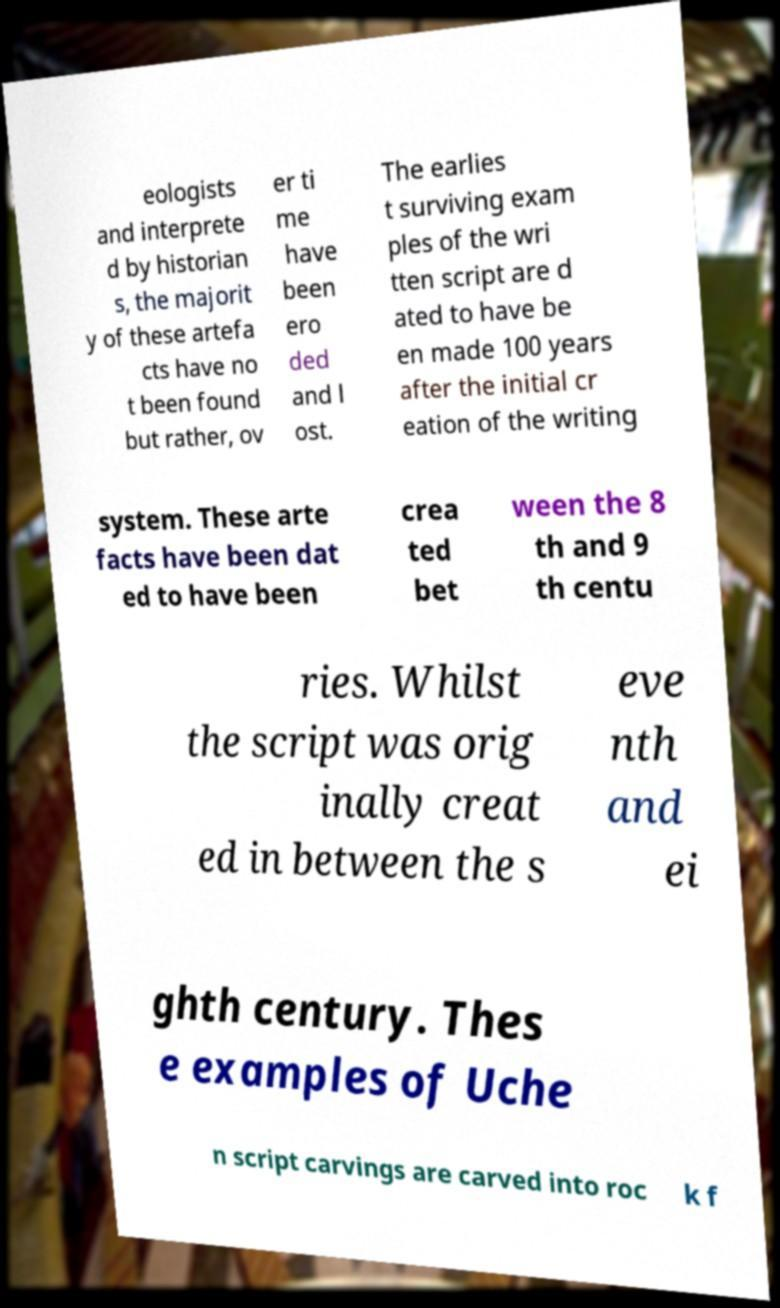Could you assist in decoding the text presented in this image and type it out clearly? eologists and interprete d by historian s, the majorit y of these artefa cts have no t been found but rather, ov er ti me have been ero ded and l ost. The earlies t surviving exam ples of the wri tten script are d ated to have be en made 100 years after the initial cr eation of the writing system. These arte facts have been dat ed to have been crea ted bet ween the 8 th and 9 th centu ries. Whilst the script was orig inally creat ed in between the s eve nth and ei ghth century. Thes e examples of Uche n script carvings are carved into roc k f 